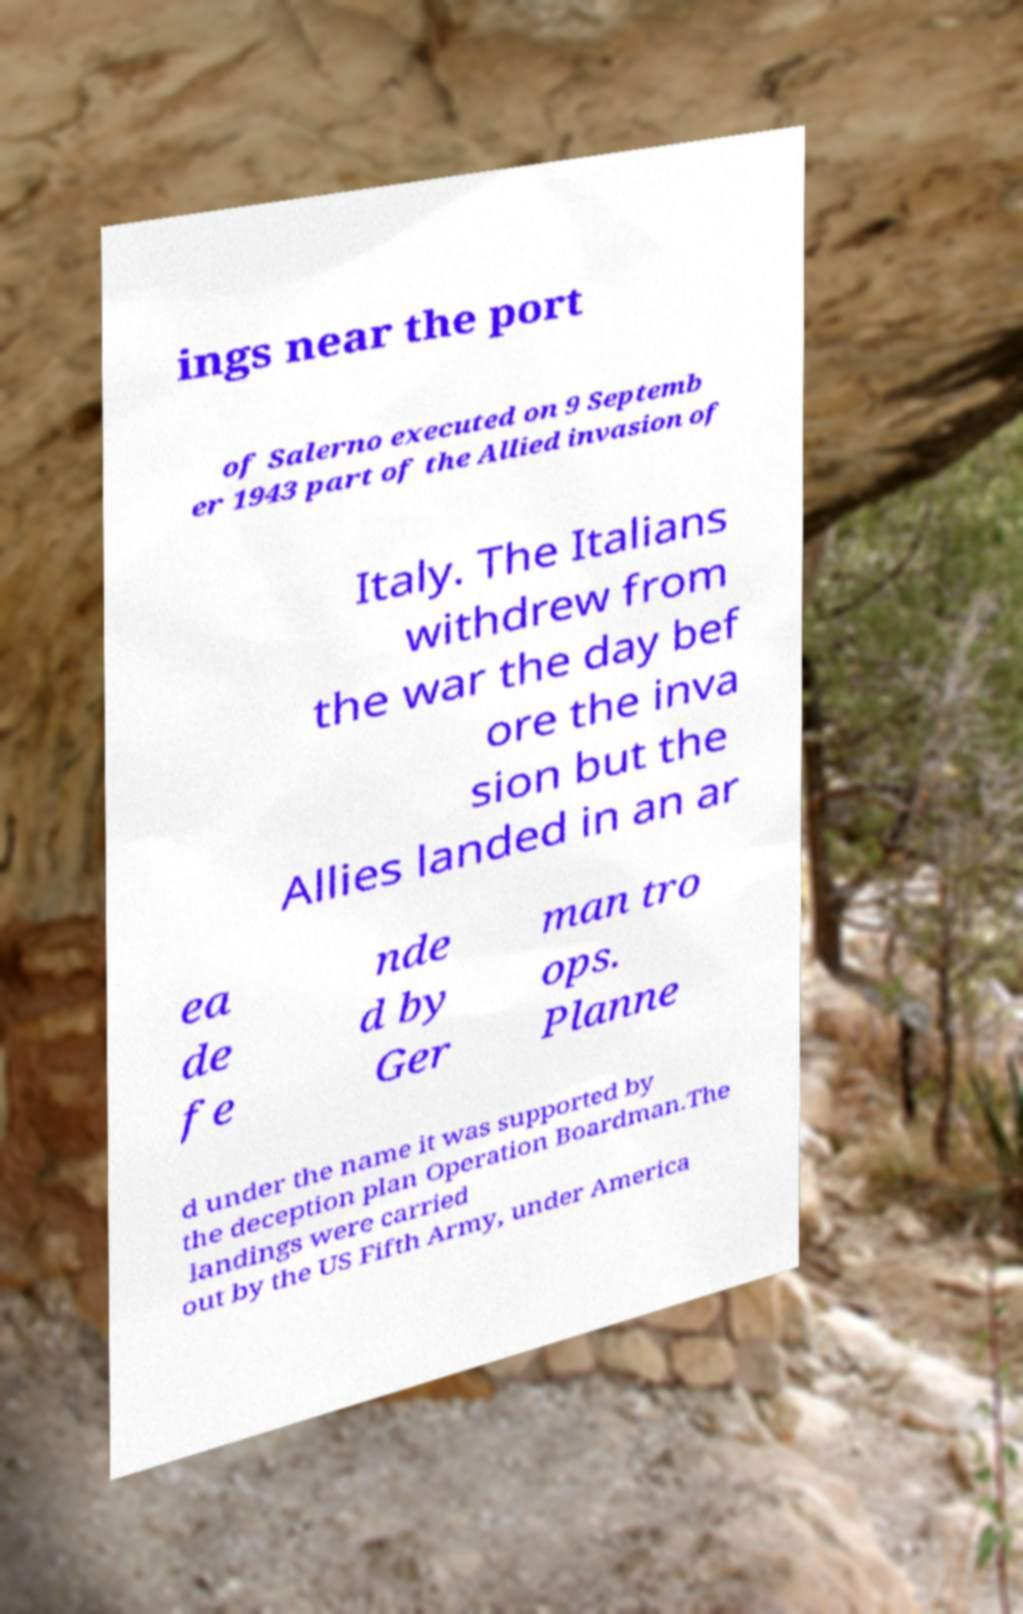Please identify and transcribe the text found in this image. ings near the port of Salerno executed on 9 Septemb er 1943 part of the Allied invasion of Italy. The Italians withdrew from the war the day bef ore the inva sion but the Allies landed in an ar ea de fe nde d by Ger man tro ops. Planne d under the name it was supported by the deception plan Operation Boardman.The landings were carried out by the US Fifth Army, under America 